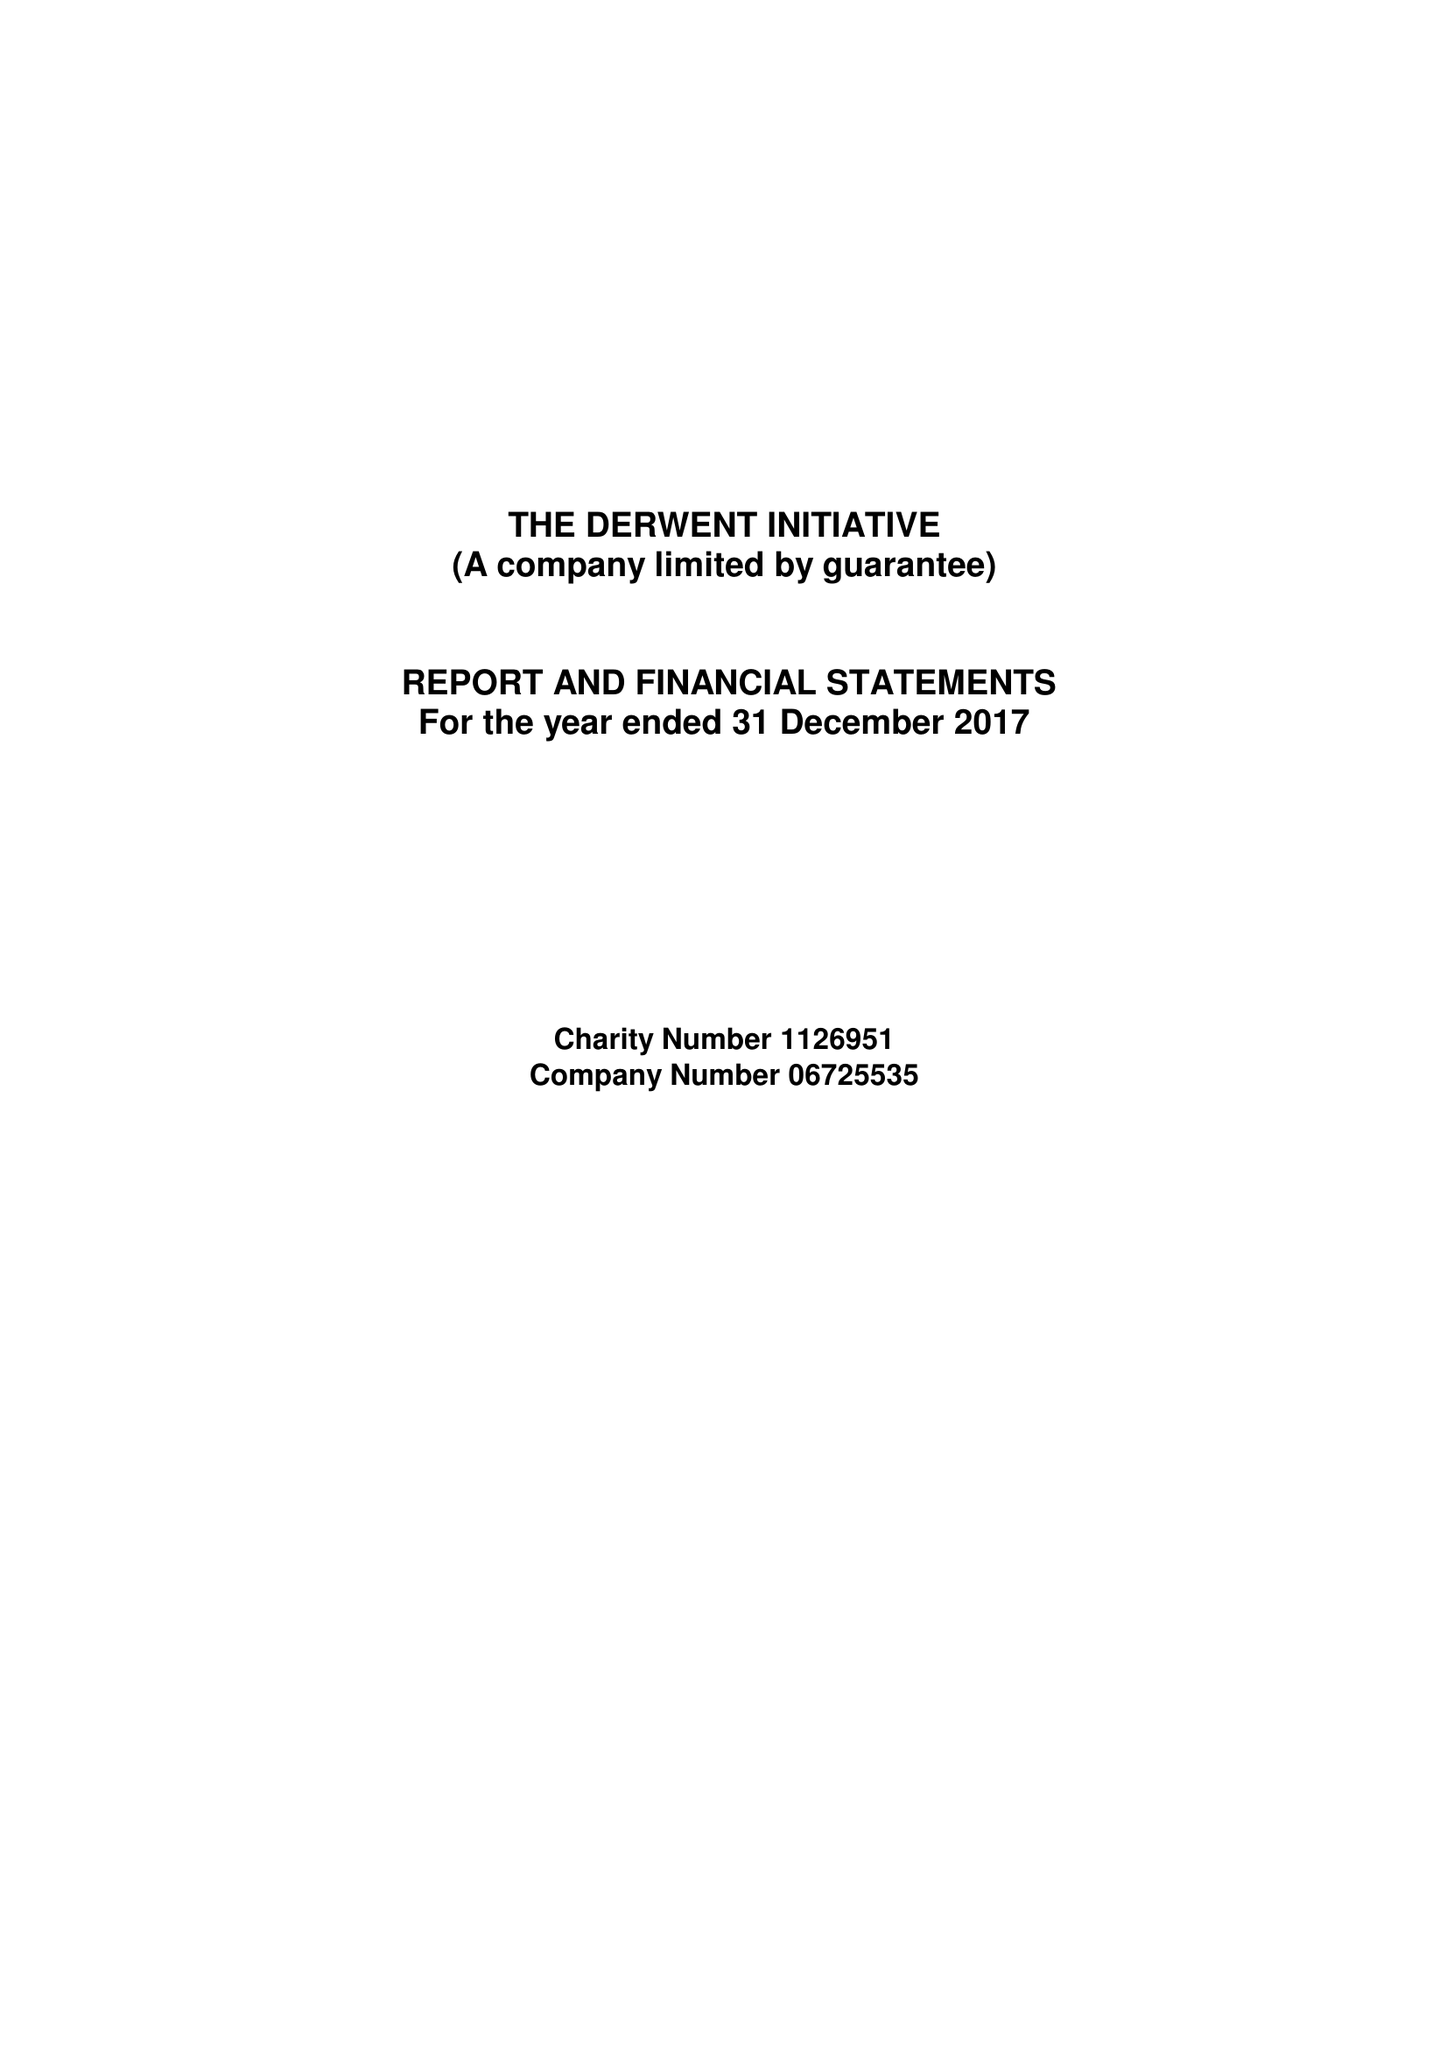What is the value for the address__post_town?
Answer the question using a single word or phrase. NEWCASTLE UPON TYNE 